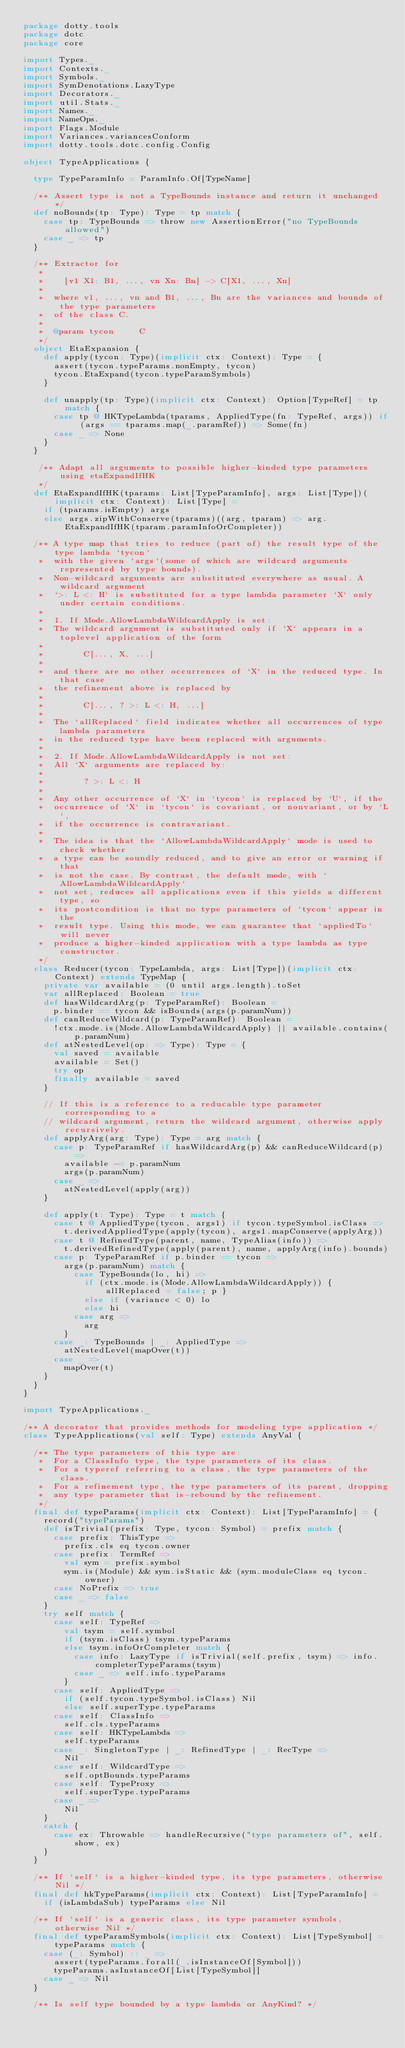<code> <loc_0><loc_0><loc_500><loc_500><_Scala_>package dotty.tools
package dotc
package core

import Types._
import Contexts._
import Symbols._
import SymDenotations.LazyType
import Decorators._
import util.Stats._
import Names._
import NameOps._
import Flags.Module
import Variances.variancesConform
import dotty.tools.dotc.config.Config

object TypeApplications {

  type TypeParamInfo = ParamInfo.Of[TypeName]

  /** Assert type is not a TypeBounds instance and return it unchanged */
  def noBounds(tp: Type): Type = tp match {
    case tp: TypeBounds => throw new AssertionError("no TypeBounds allowed")
    case _ => tp
  }

  /** Extractor for
   *
   *    [v1 X1: B1, ..., vn Xn: Bn] -> C[X1, ..., Xn]
   *
   *  where v1, ..., vn and B1, ..., Bn are the variances and bounds of the type parameters
   *  of the class C.
   *
   *  @param tycon     C
   */
  object EtaExpansion {
    def apply(tycon: Type)(implicit ctx: Context): Type = {
      assert(tycon.typeParams.nonEmpty, tycon)
      tycon.EtaExpand(tycon.typeParamSymbols)
    }

    def unapply(tp: Type)(implicit ctx: Context): Option[TypeRef] = tp match {
      case tp @ HKTypeLambda(tparams, AppliedType(fn: TypeRef, args)) if (args == tparams.map(_.paramRef)) => Some(fn)
      case _ => None
    }
  }

   /** Adapt all arguments to possible higher-kinded type parameters using etaExpandIfHK
   */
  def EtaExpandIfHK(tparams: List[TypeParamInfo], args: List[Type])(implicit ctx: Context): List[Type] =
    if (tparams.isEmpty) args
    else args.zipWithConserve(tparams)((arg, tparam) => arg.EtaExpandIfHK(tparam.paramInfoOrCompleter))

  /** A type map that tries to reduce (part of) the result type of the type lambda `tycon`
   *  with the given `args`(some of which are wildcard arguments represented by type bounds).
   *  Non-wildcard arguments are substituted everywhere as usual. A wildcard argument
   *  `>: L <: H` is substituted for a type lambda parameter `X` only under certain conditions.
   *
   *  1. If Mode.AllowLambdaWildcardApply is set:
   *  The wildcard argument is substituted only if `X` appears in a toplevel application of the form
   *
   *        C[..., X, ...]
   *
   *  and there are no other occurrences of `X` in the reduced type. In that case
   *  the refinement above is replaced by
   *
   *        C[..., ? >: L <: H, ...]
   *
   *  The `allReplaced` field indicates whether all occurrences of type lambda parameters
   *  in the reduced type have been replaced with arguments.
   *
   *  2. If Mode.AllowLambdaWildcardApply is not set:
   *  All `X` arguments are replaced by:
   *
   *        ? >: L <: H
   *
   *  Any other occurrence of `X` in `tycon` is replaced by `U`, if the
   *  occurrence of `X` in `tycon` is covariant, or nonvariant, or by `L`,
   *  if the occurrence is contravariant.
   *
   *  The idea is that the `AllowLambdaWildcardApply` mode is used to check whether
   *  a type can be soundly reduced, and to give an error or warning if that
   *  is not the case. By contrast, the default mode, with `AllowLambdaWildcardApply`
   *  not set, reduces all applications even if this yields a different type, so
   *  its postcondition is that no type parameters of `tycon` appear in the
   *  result type. Using this mode, we can guarantee that `appliedTo` will never
   *  produce a higher-kinded application with a type lambda as type constructor.
   */
  class Reducer(tycon: TypeLambda, args: List[Type])(implicit ctx: Context) extends TypeMap {
    private var available = (0 until args.length).toSet
    var allReplaced: Boolean = true
    def hasWildcardArg(p: TypeParamRef): Boolean =
      p.binder == tycon && isBounds(args(p.paramNum))
    def canReduceWildcard(p: TypeParamRef): Boolean =
      !ctx.mode.is(Mode.AllowLambdaWildcardApply) || available.contains(p.paramNum)
    def atNestedLevel(op: => Type): Type = {
      val saved = available
      available = Set()
      try op
      finally available = saved
    }

    // If this is a reference to a reducable type parameter corresponding to a
    // wildcard argument, return the wildcard argument, otherwise apply recursively.
    def applyArg(arg: Type): Type = arg match {
      case p: TypeParamRef if hasWildcardArg(p) && canReduceWildcard(p) =>
        available -= p.paramNum
        args(p.paramNum)
      case _ =>
        atNestedLevel(apply(arg))
    }

    def apply(t: Type): Type = t match {
      case t @ AppliedType(tycon, args1) if tycon.typeSymbol.isClass =>
        t.derivedAppliedType(apply(tycon), args1.mapConserve(applyArg))
      case t @ RefinedType(parent, name, TypeAlias(info)) =>
        t.derivedRefinedType(apply(parent), name, applyArg(info).bounds)
      case p: TypeParamRef if p.binder == tycon =>
        args(p.paramNum) match {
          case TypeBounds(lo, hi) =>
            if (ctx.mode.is(Mode.AllowLambdaWildcardApply)) { allReplaced = false; p }
            else if (variance < 0) lo
            else hi
          case arg =>
            arg
        }
      case _: TypeBounds | _: AppliedType =>
        atNestedLevel(mapOver(t))
      case _ =>
        mapOver(t)
    }
  }
}

import TypeApplications._

/** A decorator that provides methods for modeling type application */
class TypeApplications(val self: Type) extends AnyVal {

  /** The type parameters of this type are:
   *  For a ClassInfo type, the type parameters of its class.
   *  For a typeref referring to a class, the type parameters of the class.
   *  For a refinement type, the type parameters of its parent, dropping
   *  any type parameter that is-rebound by the refinement.
   */
  final def typeParams(implicit ctx: Context): List[TypeParamInfo] = {
    record("typeParams")
    def isTrivial(prefix: Type, tycon: Symbol) = prefix match {
      case prefix: ThisType =>
        prefix.cls eq tycon.owner
      case prefix: TermRef =>
        val sym = prefix.symbol
        sym.is(Module) && sym.isStatic && (sym.moduleClass eq tycon.owner)
      case NoPrefix => true
      case _ => false
    }
    try self match {
      case self: TypeRef =>
        val tsym = self.symbol
        if (tsym.isClass) tsym.typeParams
        else tsym.infoOrCompleter match {
          case info: LazyType if isTrivial(self.prefix, tsym) => info.completerTypeParams(tsym)
          case _ => self.info.typeParams
        }
      case self: AppliedType =>
        if (self.tycon.typeSymbol.isClass) Nil
        else self.superType.typeParams
      case self: ClassInfo =>
        self.cls.typeParams
      case self: HKTypeLambda =>
        self.typeParams
      case _: SingletonType | _: RefinedType | _: RecType =>
        Nil
      case self: WildcardType =>
        self.optBounds.typeParams
      case self: TypeProxy =>
        self.superType.typeParams
      case _ =>
        Nil
    }
    catch {
      case ex: Throwable => handleRecursive("type parameters of", self.show, ex)
    }
  }

  /** If `self` is a higher-kinded type, its type parameters, otherwise Nil */
  final def hkTypeParams(implicit ctx: Context): List[TypeParamInfo] =
    if (isLambdaSub) typeParams else Nil

  /** If `self` is a generic class, its type parameter symbols, otherwise Nil */
  final def typeParamSymbols(implicit ctx: Context): List[TypeSymbol] = typeParams match {
    case (_: Symbol) :: _ =>
      assert(typeParams.forall(_.isInstanceOf[Symbol]))
      typeParams.asInstanceOf[List[TypeSymbol]]
    case _ => Nil
  }

  /** Is self type bounded by a type lambda or AnyKind? */</code> 